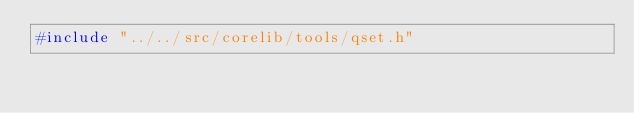Convert code to text. <code><loc_0><loc_0><loc_500><loc_500><_C_>#include "../../src/corelib/tools/qset.h"
</code> 